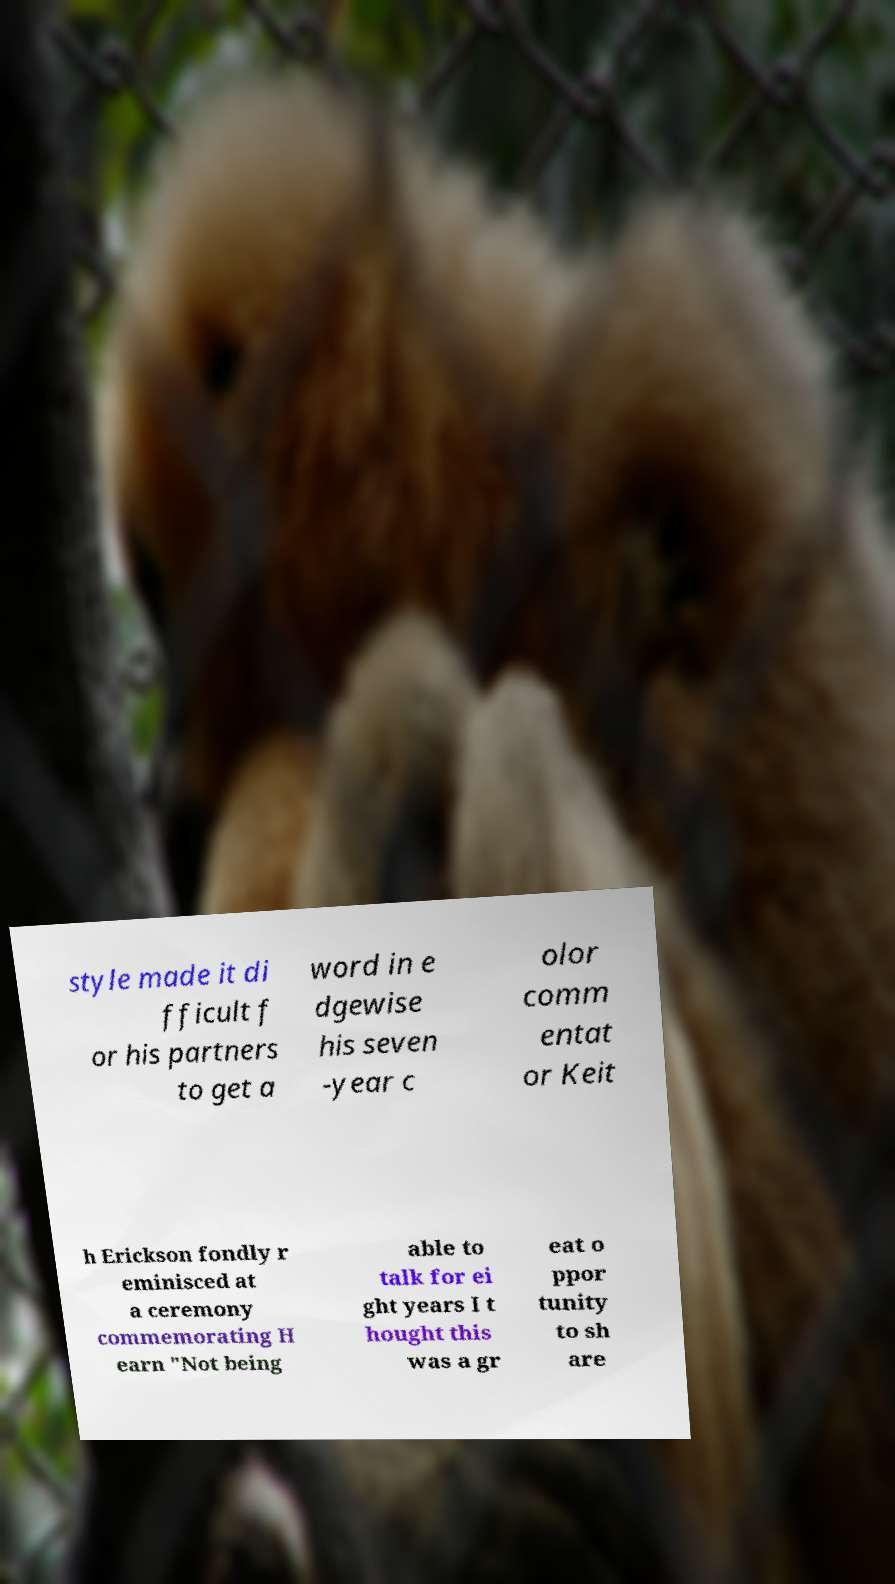I need the written content from this picture converted into text. Can you do that? style made it di fficult f or his partners to get a word in e dgewise his seven -year c olor comm entat or Keit h Erickson fondly r eminisced at a ceremony commemorating H earn "Not being able to talk for ei ght years I t hought this was a gr eat o ppor tunity to sh are 